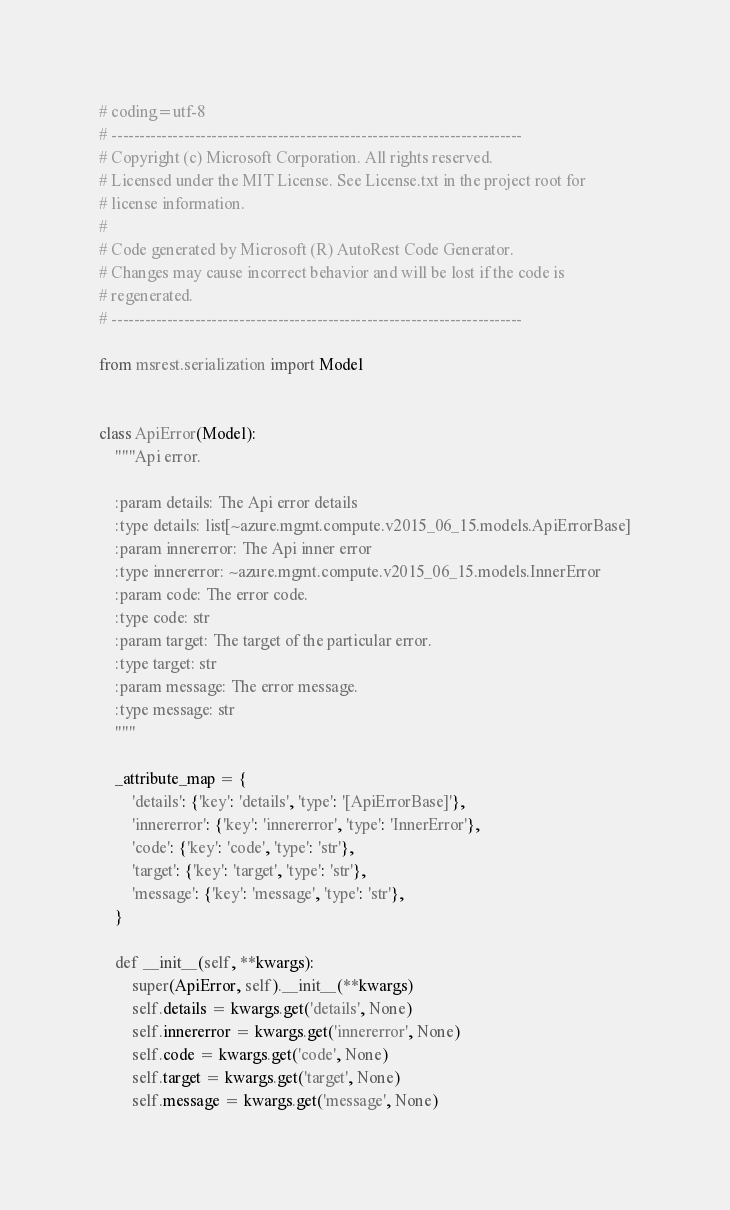<code> <loc_0><loc_0><loc_500><loc_500><_Python_># coding=utf-8
# --------------------------------------------------------------------------
# Copyright (c) Microsoft Corporation. All rights reserved.
# Licensed under the MIT License. See License.txt in the project root for
# license information.
#
# Code generated by Microsoft (R) AutoRest Code Generator.
# Changes may cause incorrect behavior and will be lost if the code is
# regenerated.
# --------------------------------------------------------------------------

from msrest.serialization import Model


class ApiError(Model):
    """Api error.

    :param details: The Api error details
    :type details: list[~azure.mgmt.compute.v2015_06_15.models.ApiErrorBase]
    :param innererror: The Api inner error
    :type innererror: ~azure.mgmt.compute.v2015_06_15.models.InnerError
    :param code: The error code.
    :type code: str
    :param target: The target of the particular error.
    :type target: str
    :param message: The error message.
    :type message: str
    """

    _attribute_map = {
        'details': {'key': 'details', 'type': '[ApiErrorBase]'},
        'innererror': {'key': 'innererror', 'type': 'InnerError'},
        'code': {'key': 'code', 'type': 'str'},
        'target': {'key': 'target', 'type': 'str'},
        'message': {'key': 'message', 'type': 'str'},
    }

    def __init__(self, **kwargs):
        super(ApiError, self).__init__(**kwargs)
        self.details = kwargs.get('details', None)
        self.innererror = kwargs.get('innererror', None)
        self.code = kwargs.get('code', None)
        self.target = kwargs.get('target', None)
        self.message = kwargs.get('message', None)
</code> 